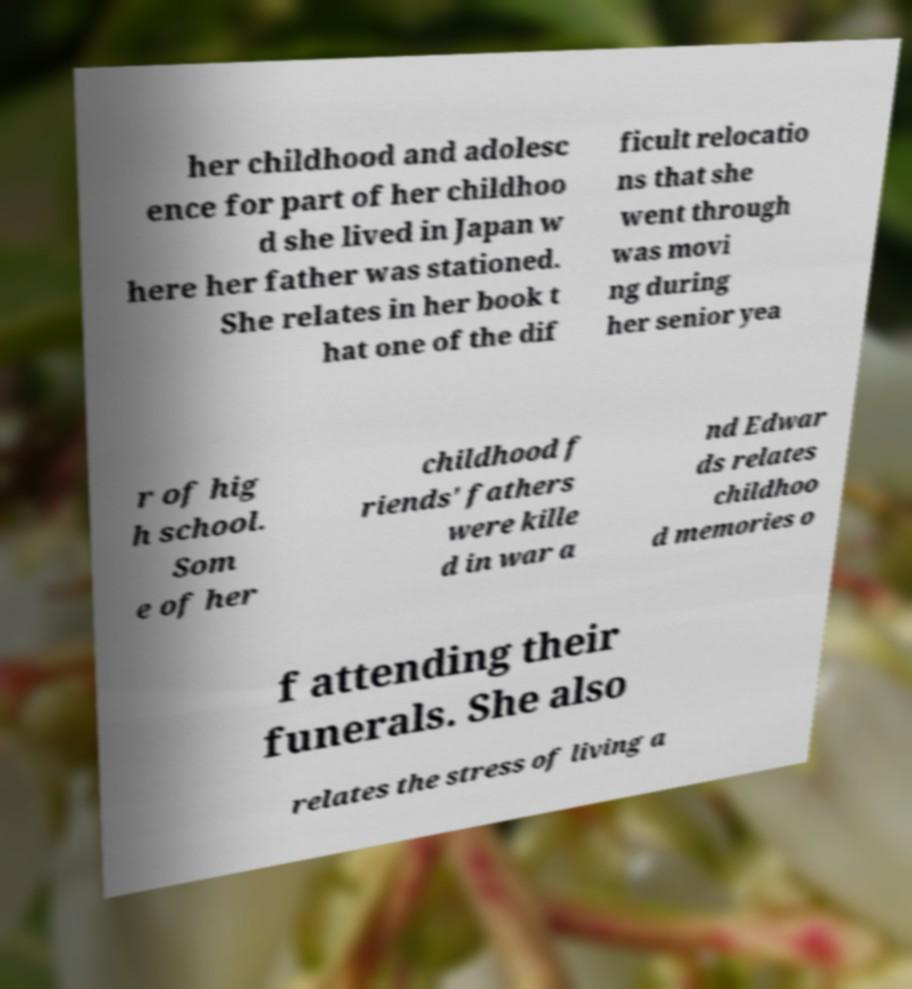Can you accurately transcribe the text from the provided image for me? her childhood and adolesc ence for part of her childhoo d she lived in Japan w here her father was stationed. She relates in her book t hat one of the dif ficult relocatio ns that she went through was movi ng during her senior yea r of hig h school. Som e of her childhood f riends' fathers were kille d in war a nd Edwar ds relates childhoo d memories o f attending their funerals. She also relates the stress of living a 